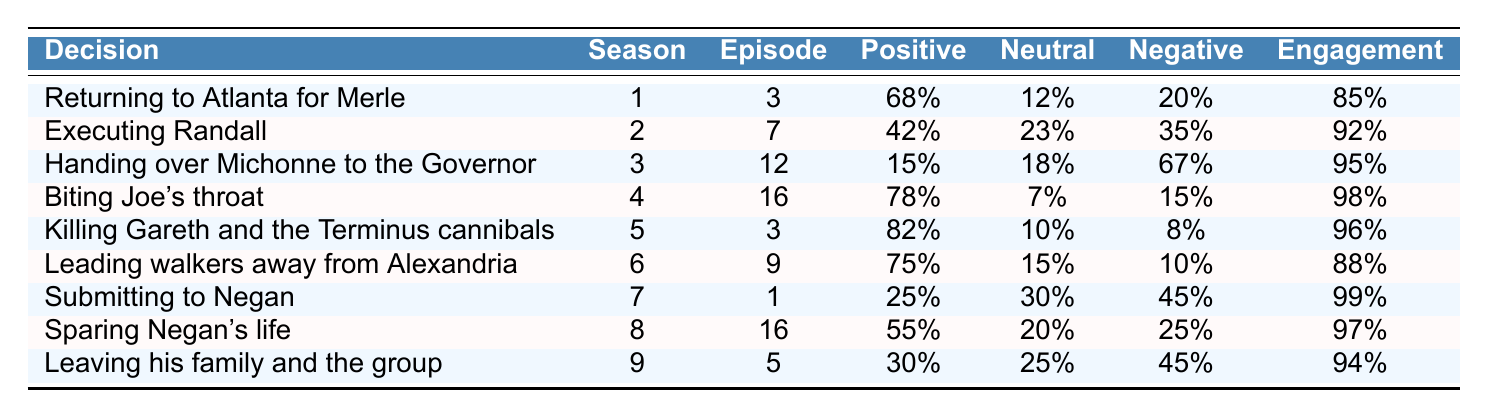What is the decision with the highest positive sentiment? Looking at the table, the decision with the highest positive sentiment is "Killing Gareth and the Terminus cannibals," which has a positive sentiment of 82%.
Answer: Killing Gareth and the Terminus cannibals Which decision received the least positive sentiment? The decision that received the least positive sentiment is "Handing over Michonne to the Governor," with only 15% positive sentiment.
Answer: Handing over Michonne to the Governor How many decisions have negative sentiment above 40%? Counting the decisions that have a negative sentiment greater than 40%, we find three: "Handing over Michonne to the Governor," "Submitting to Negan," and "Leaving his family and the group."
Answer: 3 What was the viewer engagement for "Biting Joe's throat"? Referring to the table, the viewer engagement for "Biting Joe's throat" is 98%.
Answer: 98% What is the average positive sentiment of all decisions? Adding up all the positive sentiments (68% + 42% + 15% + 78% + 82% + 75% + 25% + 55% + 30%) gives 430%. Dividing by 9 gives an average of about 47.78%.
Answer: 47.78% Was "Submitting to Negan" the decision with the highest viewer engagement? The table shows that "Submitting to Negan" has a viewer engagement of 99%, which is higher than any other decision listed. Therefore, this statement is true.
Answer: Yes Which decision has the highest percentage of neutral sentiment? The highest percentage of neutral sentiment is for "Submitting to Negan," which has 30% neutral sentiment.
Answer: Submitting to Negan Compare the positive sentiment of "Returning to Atlanta for Merle" and "Sparing Negan's life." "Returning to Atlanta for Merle" has 68% positive sentiment, while "Sparing Negan's life" has 55%. The difference between them is 13%, with "Returning to Atlanta for Merle" being higher.
Answer: 13% What is the total viewer engagement for all decisions? Summing the viewer engagement values (85 + 92 + 95 + 98 + 96 + 88 + 99 + 97 + 94) results in a total of 924.
Answer: 924 Which decision had the lowest engagement rate? The decision with the lowest viewer engagement is "Leading walkers away from Alexandria," with 88% engagement.
Answer: Leading walkers away from Alexandria Is there a decision where the negative sentiment exceeds 60%? Yes, the decision "Handing over Michonne to the Governor" has a negative sentiment of 67%, which exceeds 60%.
Answer: Yes 